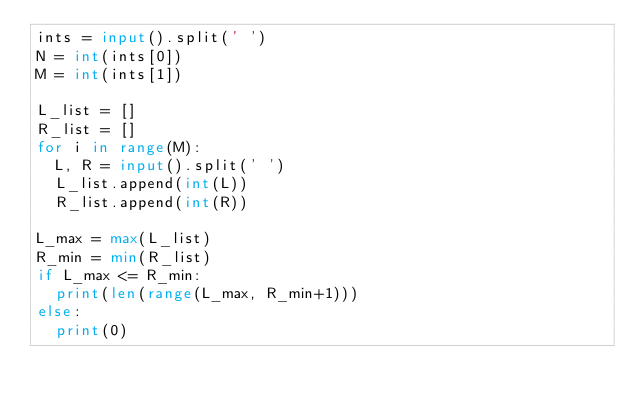<code> <loc_0><loc_0><loc_500><loc_500><_Python_>ints = input().split(' ')
N = int(ints[0])
M = int(ints[1])

L_list = []
R_list = []
for i in range(M):
	L, R = input().split(' ')
	L_list.append(int(L))
	R_list.append(int(R))

L_max = max(L_list)
R_min = min(R_list)
if L_max <= R_min:
	print(len(range(L_max, R_min+1)))
else:
	print(0)</code> 